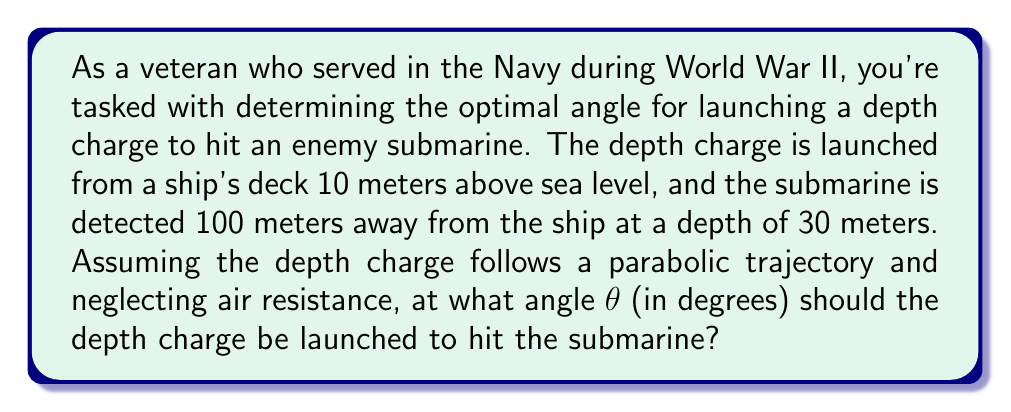What is the answer to this math problem? Let's approach this step-by-step:

1) We can model the trajectory of the depth charge using the equation of a parabola:

   $$y = -a(x-h)^2 + k$$

   where (h,k) is the vertex of the parabola.

2) We know two points on this parabola:
   - The launch point: (0, 10)
   - The target point: (100, -30)

3) The angle of launch θ is related to the slope of the tangent line at the launch point. This slope is the derivative of our parabola equation at x = 0.

4) Let's set up our equation using the launch point:

   $$10 = -a(0-h)^2 + k$$
   $$10 = -ah^2 + k$$ ... (1)

5) Now use the target point:

   $$-30 = -a(100-h)^2 + k$$ ... (2)

6) Subtracting (1) from (2):

   $$-40 = -a(10000-200h+h^2) + ah^2$$
   $$-40 = -10000a + 200ah - ah^2 + ah^2$$
   $$-40 = -10000a + 200ah$$
   $$40 = 10000a - 200ah$$ ... (3)

7) The derivative of our parabola equation is:

   $$\frac{dy}{dx} = -2a(x-h)$$

8) At the launch point (0,10), this should equal tan(θ):

   $$\tan(\theta) = 2ah$$ ... (4)

9) From (3) and (4), we have two equations and two unknowns (a and h). Solving these simultaneously:

   From (3): $$a = \frac{40+200ah}{10000}$$ ... (5)

   Substituting (5) into (4):

   $$\tan(\theta) = 2h(\frac{40+200ah}{10000})$$
   $$10000\tan(\theta) = 80h + 400ah^2$$
   $$10000\tan(\theta) = 80h + 200h\tan(\theta)$$
   $$9800\tan(\theta) = 80h$$
   $$h = 122.5\tan(\theta)$$ ... (6)

10) Substituting (6) back into (5):

    $$a = \frac{40+200(122.5\tan(\theta))\tan(\theta)}{10000}$$
    $$a = \frac{40+24500\tan^2(\theta)}{10000}$$ ... (7)

11) Now, using the target point (100, -30) in our original equation:

    $$-30 = -a(100-h)^2 + k$$
    $$-30 = -a(100-122.5\tan(\theta))^2 + 10$$ (using (1) for k)

12) Substituting (7) for a:

    $$-40 = -(\frac{40+24500\tan^2(\theta)}{10000})(100-122.5\tan(\theta))^2$$

13) This equation can be solved numerically to get:

    $$\theta ≈ 14.04°$$
Answer: The optimal angle for launching the depth charge is approximately 14.04°. 